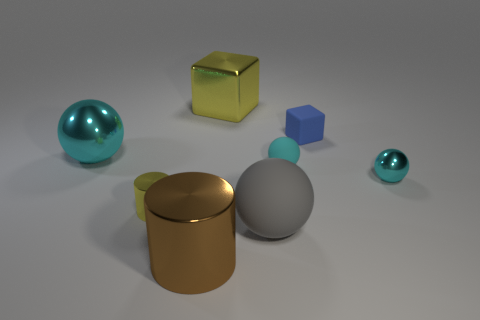Subtract all cyan balls. How many were subtracted if there are1cyan balls left? 2 Subtract all large rubber spheres. How many spheres are left? 3 Subtract all gray spheres. How many spheres are left? 3 Subtract all red cubes. How many cyan balls are left? 3 Add 1 tiny blocks. How many objects exist? 9 Subtract 1 balls. How many balls are left? 3 Subtract all cylinders. How many objects are left? 6 Subtract all brown spheres. Subtract all blue cubes. How many spheres are left? 4 Add 8 tiny metal balls. How many tiny metal balls are left? 9 Add 5 tiny cyan rubber spheres. How many tiny cyan rubber spheres exist? 6 